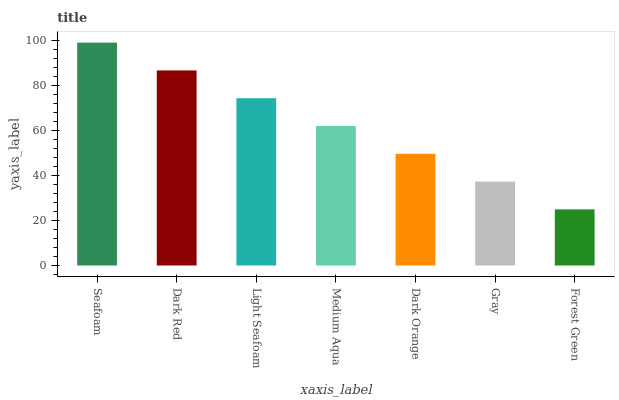Is Forest Green the minimum?
Answer yes or no. Yes. Is Seafoam the maximum?
Answer yes or no. Yes. Is Dark Red the minimum?
Answer yes or no. No. Is Dark Red the maximum?
Answer yes or no. No. Is Seafoam greater than Dark Red?
Answer yes or no. Yes. Is Dark Red less than Seafoam?
Answer yes or no. Yes. Is Dark Red greater than Seafoam?
Answer yes or no. No. Is Seafoam less than Dark Red?
Answer yes or no. No. Is Medium Aqua the high median?
Answer yes or no. Yes. Is Medium Aqua the low median?
Answer yes or no. Yes. Is Dark Red the high median?
Answer yes or no. No. Is Forest Green the low median?
Answer yes or no. No. 